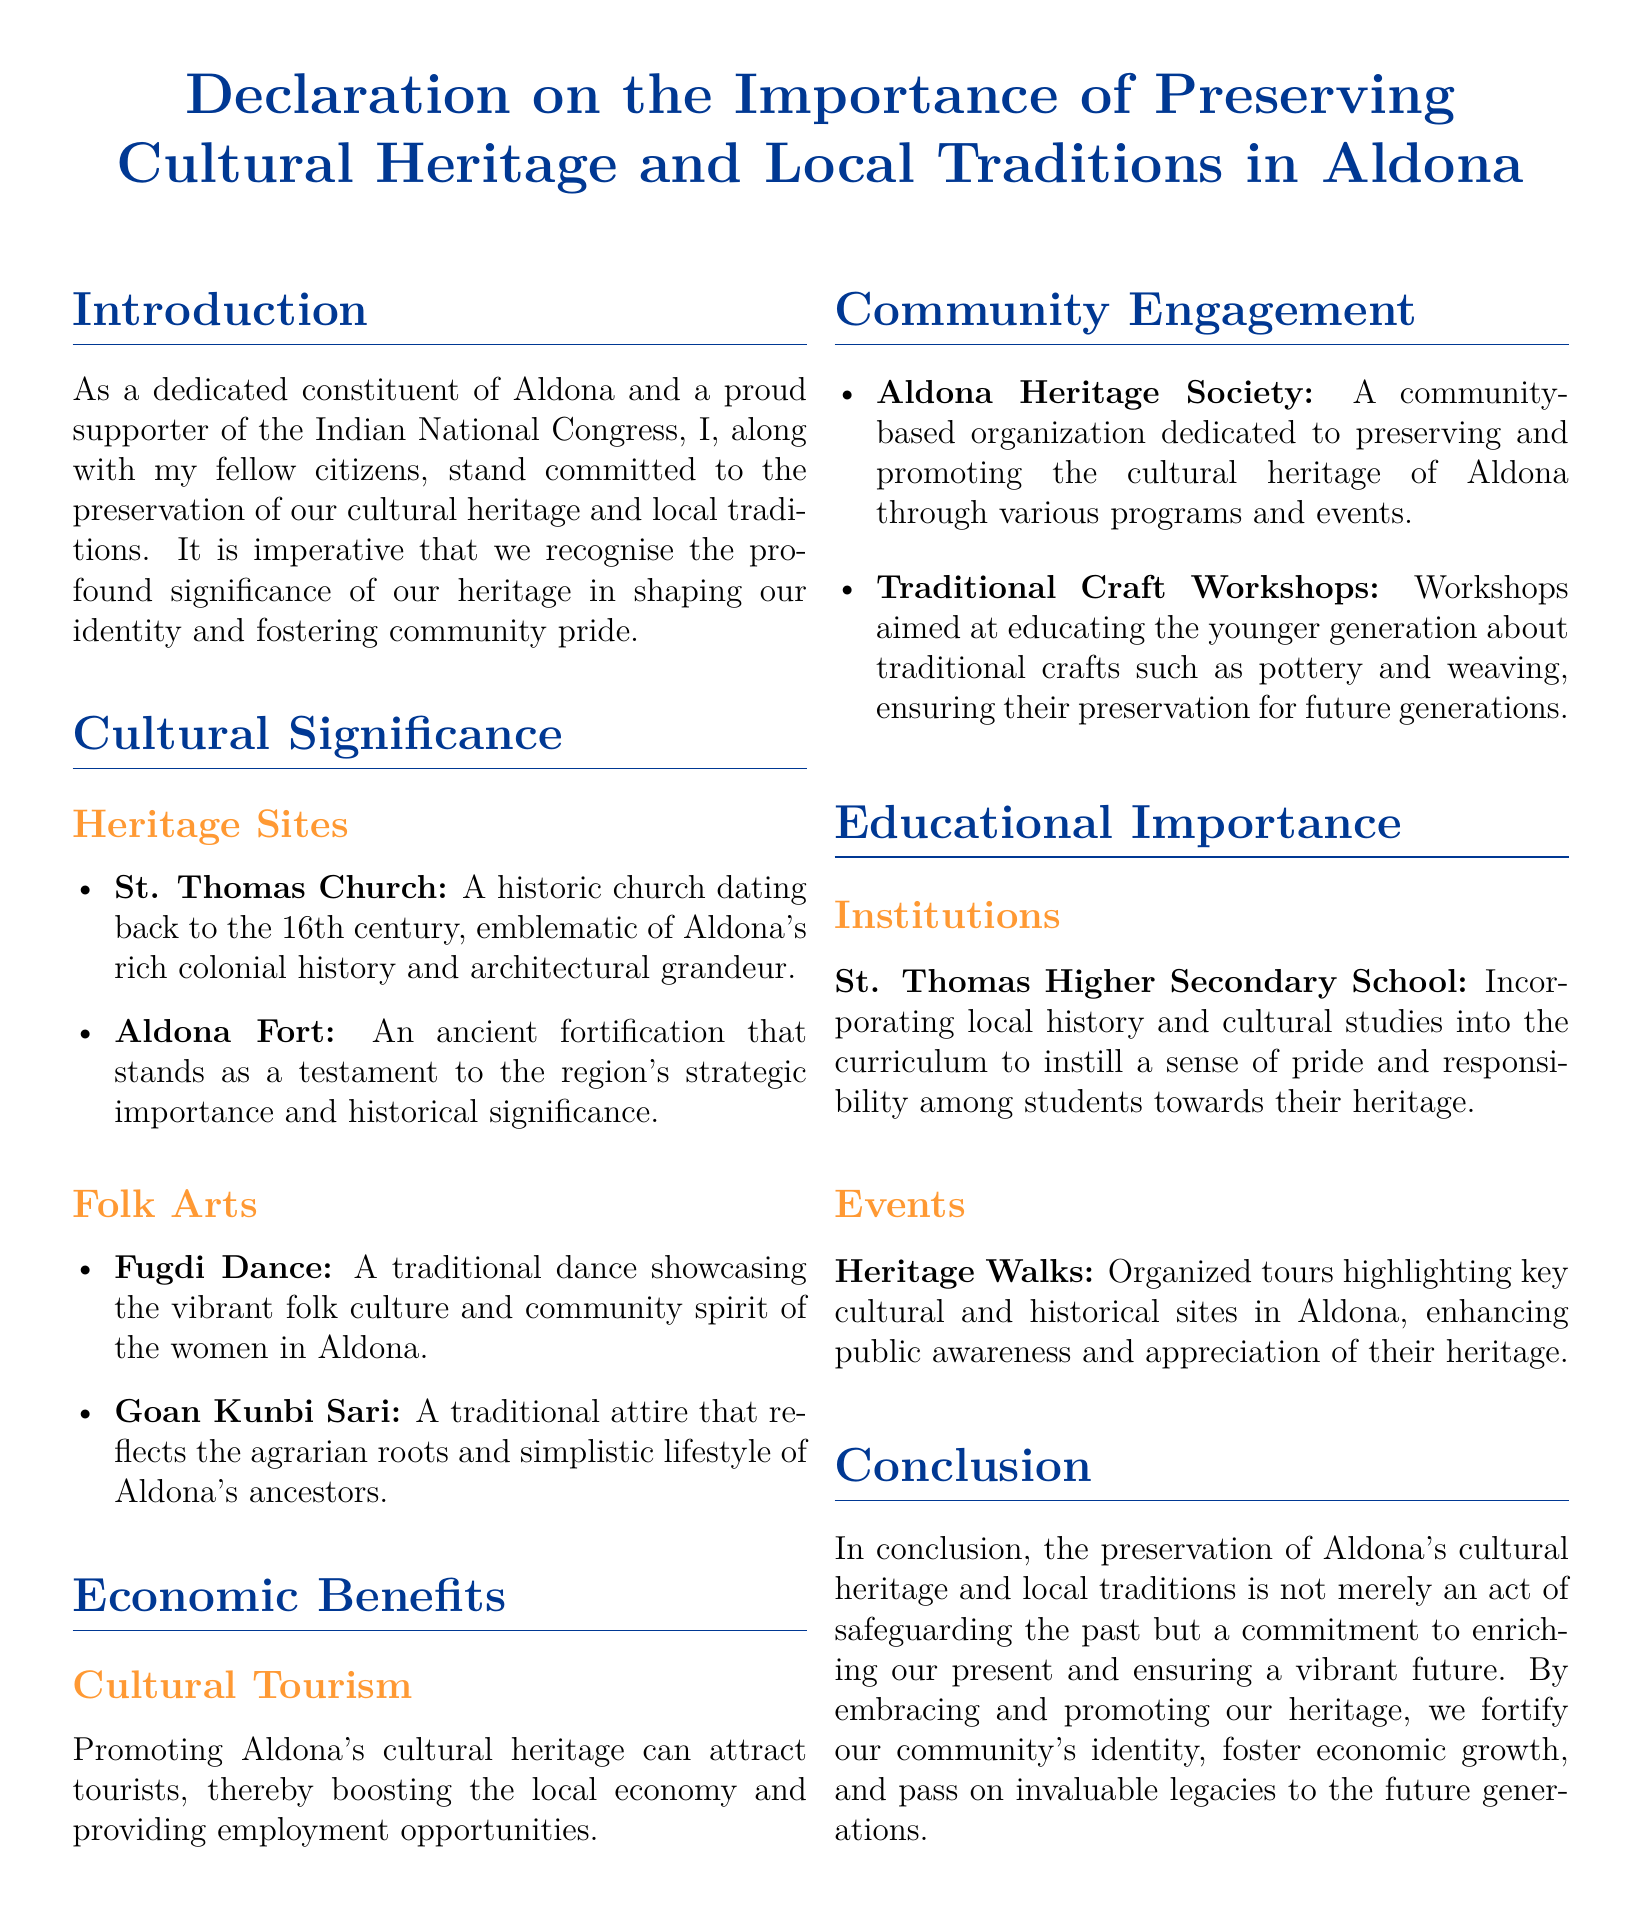what is the name of the historic church mentioned? The name of the historic church located in Aldona, as mentioned in the document, is St. Thomas Church.
Answer: St. Thomas Church what century does the St. Thomas Church date back to? The document states that St. Thomas Church dates back to the 16th century.
Answer: 16th century what dance is showcased in Aldona's folk culture? The traditional dance that represents Aldona's vibrant folk culture is called Fugdi Dance.
Answer: Fugdi Dance what community organization is dedicated to preserving Aldona's cultural heritage? The community-based organization mentioned in the document that focuses on preserving Aldona's cultural heritage is the Aldona Heritage Society.
Answer: Aldona Heritage Society what type of workshops are aimed at educating the younger generation? The document indicates that traditional craft workshops are aimed at educating the younger generation.
Answer: Traditional Craft Workshops what is the economic benefit of promoting Aldona's cultural heritage? The document suggests that promoting Aldona's cultural heritage can attract tourists, thereby boosting the local economy.
Answer: Cultural Tourism what institution incorporates local history into its curriculum? St. Thomas Higher Secondary School is the institution mentioned that incorporates local history and cultural studies into its curriculum.
Answer: St. Thomas Higher Secondary School what are organized tours that highlight key cultural sites called? The organized tours that highlight key cultural and historical sites in Aldona are known as Heritage Walks.
Answer: Heritage Walks what is the conclusion about preserving cultural heritage in Aldona? The conclusion expresses that preserving Aldona's cultural heritage enriches our present and ensures a vibrant future.
Answer: Enriches our present and ensures a vibrant future 